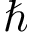<formula> <loc_0><loc_0><loc_500><loc_500>\hbar</formula> 